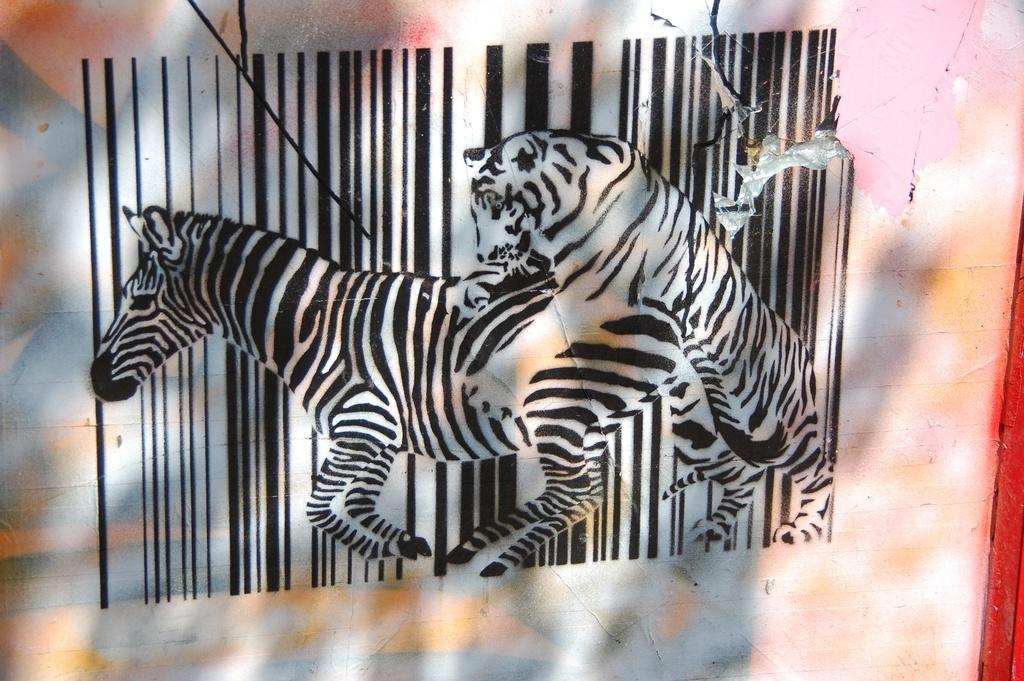How would you summarize this image in a sentence or two? In this picture I can see some animals painting on the wall. 